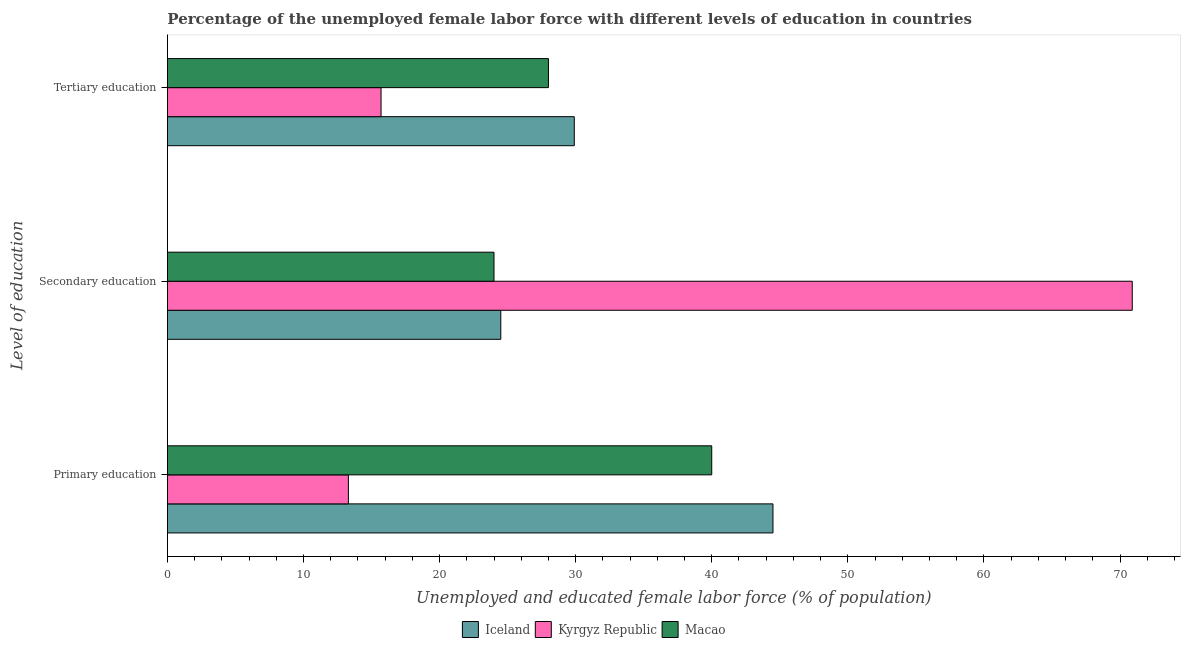How many groups of bars are there?
Offer a very short reply. 3. How many bars are there on the 2nd tick from the top?
Offer a very short reply. 3. How many bars are there on the 3rd tick from the bottom?
Provide a short and direct response. 3. What is the percentage of female labor force who received tertiary education in Kyrgyz Republic?
Ensure brevity in your answer.  15.7. Across all countries, what is the maximum percentage of female labor force who received tertiary education?
Your answer should be compact. 29.9. Across all countries, what is the minimum percentage of female labor force who received primary education?
Ensure brevity in your answer.  13.3. In which country was the percentage of female labor force who received tertiary education maximum?
Keep it short and to the point. Iceland. In which country was the percentage of female labor force who received primary education minimum?
Provide a succinct answer. Kyrgyz Republic. What is the total percentage of female labor force who received secondary education in the graph?
Make the answer very short. 119.4. What is the difference between the percentage of female labor force who received primary education in Iceland and that in Macao?
Keep it short and to the point. 4.5. What is the difference between the percentage of female labor force who received primary education in Macao and the percentage of female labor force who received secondary education in Kyrgyz Republic?
Provide a succinct answer. -30.9. What is the average percentage of female labor force who received primary education per country?
Offer a very short reply. 32.6. What is the difference between the percentage of female labor force who received secondary education and percentage of female labor force who received tertiary education in Iceland?
Make the answer very short. -5.4. In how many countries, is the percentage of female labor force who received secondary education greater than 22 %?
Keep it short and to the point. 3. What is the ratio of the percentage of female labor force who received primary education in Kyrgyz Republic to that in Iceland?
Your answer should be compact. 0.3. Is the percentage of female labor force who received secondary education in Macao less than that in Iceland?
Keep it short and to the point. Yes. What is the difference between the highest and the second highest percentage of female labor force who received secondary education?
Give a very brief answer. 46.4. What is the difference between the highest and the lowest percentage of female labor force who received secondary education?
Offer a terse response. 46.9. In how many countries, is the percentage of female labor force who received tertiary education greater than the average percentage of female labor force who received tertiary education taken over all countries?
Make the answer very short. 2. What does the 3rd bar from the top in Tertiary education represents?
Provide a short and direct response. Iceland. What does the 3rd bar from the bottom in Secondary education represents?
Ensure brevity in your answer.  Macao. How many bars are there?
Provide a succinct answer. 9. How many countries are there in the graph?
Your answer should be compact. 3. Are the values on the major ticks of X-axis written in scientific E-notation?
Your answer should be compact. No. Does the graph contain any zero values?
Offer a very short reply. No. Where does the legend appear in the graph?
Offer a very short reply. Bottom center. How are the legend labels stacked?
Offer a very short reply. Horizontal. What is the title of the graph?
Your answer should be compact. Percentage of the unemployed female labor force with different levels of education in countries. Does "Brunei Darussalam" appear as one of the legend labels in the graph?
Ensure brevity in your answer.  No. What is the label or title of the X-axis?
Ensure brevity in your answer.  Unemployed and educated female labor force (% of population). What is the label or title of the Y-axis?
Your answer should be very brief. Level of education. What is the Unemployed and educated female labor force (% of population) in Iceland in Primary education?
Give a very brief answer. 44.5. What is the Unemployed and educated female labor force (% of population) in Kyrgyz Republic in Primary education?
Your answer should be compact. 13.3. What is the Unemployed and educated female labor force (% of population) of Kyrgyz Republic in Secondary education?
Your response must be concise. 70.9. What is the Unemployed and educated female labor force (% of population) in Iceland in Tertiary education?
Offer a terse response. 29.9. What is the Unemployed and educated female labor force (% of population) in Kyrgyz Republic in Tertiary education?
Keep it short and to the point. 15.7. What is the Unemployed and educated female labor force (% of population) of Macao in Tertiary education?
Your answer should be very brief. 28. Across all Level of education, what is the maximum Unemployed and educated female labor force (% of population) of Iceland?
Make the answer very short. 44.5. Across all Level of education, what is the maximum Unemployed and educated female labor force (% of population) in Kyrgyz Republic?
Your response must be concise. 70.9. Across all Level of education, what is the maximum Unemployed and educated female labor force (% of population) in Macao?
Give a very brief answer. 40. Across all Level of education, what is the minimum Unemployed and educated female labor force (% of population) in Kyrgyz Republic?
Your response must be concise. 13.3. Across all Level of education, what is the minimum Unemployed and educated female labor force (% of population) in Macao?
Your answer should be compact. 24. What is the total Unemployed and educated female labor force (% of population) in Iceland in the graph?
Provide a succinct answer. 98.9. What is the total Unemployed and educated female labor force (% of population) of Kyrgyz Republic in the graph?
Offer a very short reply. 99.9. What is the total Unemployed and educated female labor force (% of population) of Macao in the graph?
Offer a very short reply. 92. What is the difference between the Unemployed and educated female labor force (% of population) in Kyrgyz Republic in Primary education and that in Secondary education?
Ensure brevity in your answer.  -57.6. What is the difference between the Unemployed and educated female labor force (% of population) of Kyrgyz Republic in Primary education and that in Tertiary education?
Give a very brief answer. -2.4. What is the difference between the Unemployed and educated female labor force (% of population) of Iceland in Secondary education and that in Tertiary education?
Provide a succinct answer. -5.4. What is the difference between the Unemployed and educated female labor force (% of population) of Kyrgyz Republic in Secondary education and that in Tertiary education?
Make the answer very short. 55.2. What is the difference between the Unemployed and educated female labor force (% of population) in Iceland in Primary education and the Unemployed and educated female labor force (% of population) in Kyrgyz Republic in Secondary education?
Provide a succinct answer. -26.4. What is the difference between the Unemployed and educated female labor force (% of population) in Kyrgyz Republic in Primary education and the Unemployed and educated female labor force (% of population) in Macao in Secondary education?
Make the answer very short. -10.7. What is the difference between the Unemployed and educated female labor force (% of population) in Iceland in Primary education and the Unemployed and educated female labor force (% of population) in Kyrgyz Republic in Tertiary education?
Give a very brief answer. 28.8. What is the difference between the Unemployed and educated female labor force (% of population) in Iceland in Primary education and the Unemployed and educated female labor force (% of population) in Macao in Tertiary education?
Keep it short and to the point. 16.5. What is the difference between the Unemployed and educated female labor force (% of population) in Kyrgyz Republic in Primary education and the Unemployed and educated female labor force (% of population) in Macao in Tertiary education?
Offer a terse response. -14.7. What is the difference between the Unemployed and educated female labor force (% of population) in Iceland in Secondary education and the Unemployed and educated female labor force (% of population) in Macao in Tertiary education?
Ensure brevity in your answer.  -3.5. What is the difference between the Unemployed and educated female labor force (% of population) of Kyrgyz Republic in Secondary education and the Unemployed and educated female labor force (% of population) of Macao in Tertiary education?
Offer a terse response. 42.9. What is the average Unemployed and educated female labor force (% of population) in Iceland per Level of education?
Give a very brief answer. 32.97. What is the average Unemployed and educated female labor force (% of population) in Kyrgyz Republic per Level of education?
Your answer should be compact. 33.3. What is the average Unemployed and educated female labor force (% of population) in Macao per Level of education?
Offer a very short reply. 30.67. What is the difference between the Unemployed and educated female labor force (% of population) of Iceland and Unemployed and educated female labor force (% of population) of Kyrgyz Republic in Primary education?
Offer a very short reply. 31.2. What is the difference between the Unemployed and educated female labor force (% of population) of Kyrgyz Republic and Unemployed and educated female labor force (% of population) of Macao in Primary education?
Offer a terse response. -26.7. What is the difference between the Unemployed and educated female labor force (% of population) in Iceland and Unemployed and educated female labor force (% of population) in Kyrgyz Republic in Secondary education?
Your answer should be compact. -46.4. What is the difference between the Unemployed and educated female labor force (% of population) of Kyrgyz Republic and Unemployed and educated female labor force (% of population) of Macao in Secondary education?
Ensure brevity in your answer.  46.9. What is the ratio of the Unemployed and educated female labor force (% of population) in Iceland in Primary education to that in Secondary education?
Provide a succinct answer. 1.82. What is the ratio of the Unemployed and educated female labor force (% of population) in Kyrgyz Republic in Primary education to that in Secondary education?
Make the answer very short. 0.19. What is the ratio of the Unemployed and educated female labor force (% of population) in Iceland in Primary education to that in Tertiary education?
Your answer should be very brief. 1.49. What is the ratio of the Unemployed and educated female labor force (% of population) of Kyrgyz Republic in Primary education to that in Tertiary education?
Your response must be concise. 0.85. What is the ratio of the Unemployed and educated female labor force (% of population) in Macao in Primary education to that in Tertiary education?
Ensure brevity in your answer.  1.43. What is the ratio of the Unemployed and educated female labor force (% of population) in Iceland in Secondary education to that in Tertiary education?
Give a very brief answer. 0.82. What is the ratio of the Unemployed and educated female labor force (% of population) in Kyrgyz Republic in Secondary education to that in Tertiary education?
Keep it short and to the point. 4.52. What is the ratio of the Unemployed and educated female labor force (% of population) of Macao in Secondary education to that in Tertiary education?
Offer a terse response. 0.86. What is the difference between the highest and the second highest Unemployed and educated female labor force (% of population) in Iceland?
Offer a very short reply. 14.6. What is the difference between the highest and the second highest Unemployed and educated female labor force (% of population) in Kyrgyz Republic?
Offer a terse response. 55.2. What is the difference between the highest and the lowest Unemployed and educated female labor force (% of population) of Kyrgyz Republic?
Ensure brevity in your answer.  57.6. 